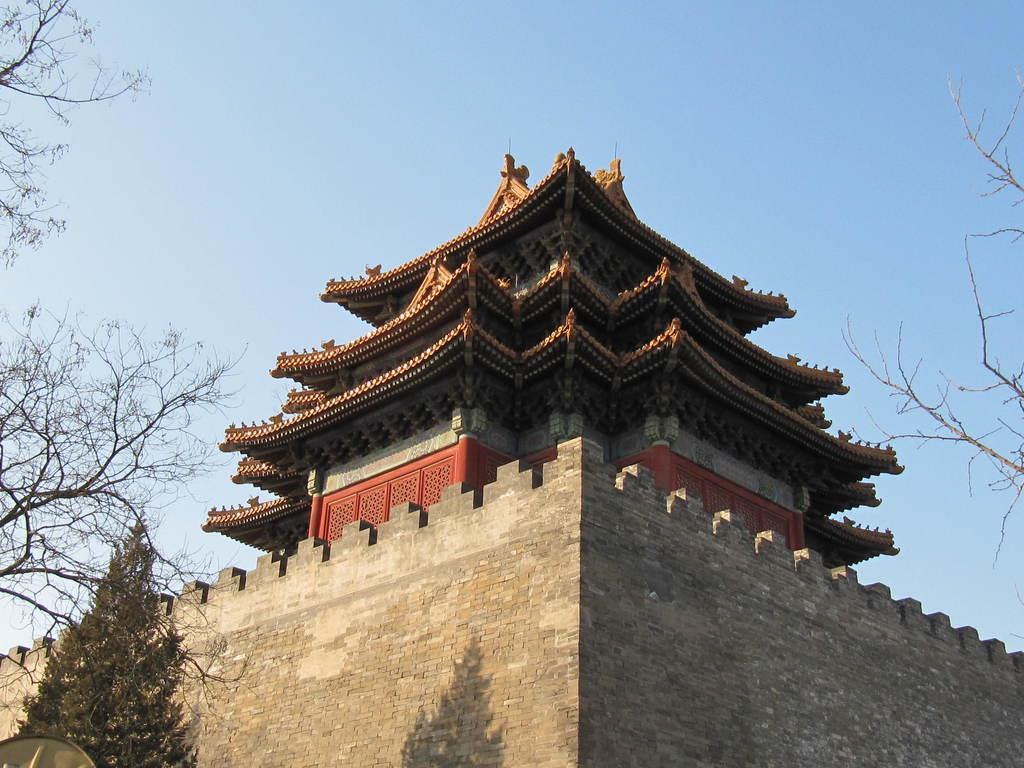How would you summarize this image in a sentence or two? This is an outside view. At the bottom there is a wall. In the middle of the image there is building. On the right and left side of the image I can see the trees. At the top of the image I can see the sky. 